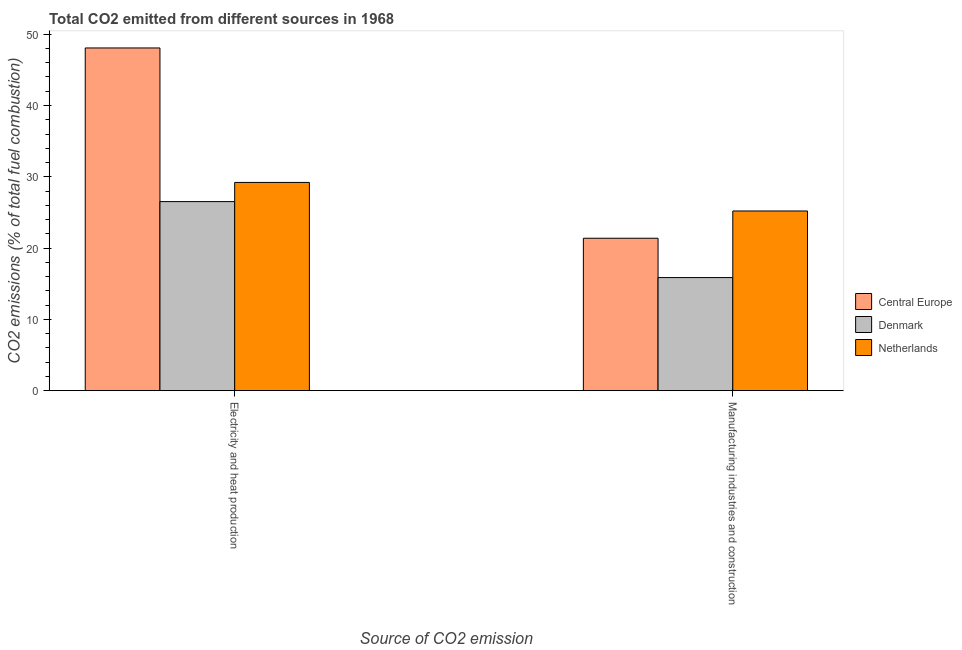How many different coloured bars are there?
Give a very brief answer. 3. Are the number of bars per tick equal to the number of legend labels?
Keep it short and to the point. Yes. How many bars are there on the 2nd tick from the left?
Offer a terse response. 3. How many bars are there on the 1st tick from the right?
Keep it short and to the point. 3. What is the label of the 2nd group of bars from the left?
Offer a terse response. Manufacturing industries and construction. What is the co2 emissions due to manufacturing industries in Denmark?
Give a very brief answer. 15.86. Across all countries, what is the maximum co2 emissions due to manufacturing industries?
Provide a succinct answer. 25.2. Across all countries, what is the minimum co2 emissions due to electricity and heat production?
Provide a succinct answer. 26.52. In which country was the co2 emissions due to manufacturing industries maximum?
Your answer should be very brief. Netherlands. In which country was the co2 emissions due to electricity and heat production minimum?
Offer a terse response. Denmark. What is the total co2 emissions due to electricity and heat production in the graph?
Give a very brief answer. 103.8. What is the difference between the co2 emissions due to manufacturing industries in Denmark and that in Central Europe?
Your answer should be very brief. -5.52. What is the difference between the co2 emissions due to manufacturing industries in Central Europe and the co2 emissions due to electricity and heat production in Denmark?
Provide a succinct answer. -5.14. What is the average co2 emissions due to electricity and heat production per country?
Provide a succinct answer. 34.6. What is the difference between the co2 emissions due to electricity and heat production and co2 emissions due to manufacturing industries in Denmark?
Offer a very short reply. 10.66. In how many countries, is the co2 emissions due to electricity and heat production greater than 12 %?
Provide a succinct answer. 3. What is the ratio of the co2 emissions due to electricity and heat production in Denmark to that in Netherlands?
Give a very brief answer. 0.91. Is the co2 emissions due to electricity and heat production in Central Europe less than that in Denmark?
Ensure brevity in your answer.  No. In how many countries, is the co2 emissions due to manufacturing industries greater than the average co2 emissions due to manufacturing industries taken over all countries?
Your answer should be compact. 2. What does the 1st bar from the left in Electricity and heat production represents?
Offer a very short reply. Central Europe. What is the difference between two consecutive major ticks on the Y-axis?
Keep it short and to the point. 10. Are the values on the major ticks of Y-axis written in scientific E-notation?
Your response must be concise. No. Does the graph contain any zero values?
Keep it short and to the point. No. Does the graph contain grids?
Your answer should be very brief. No. What is the title of the graph?
Your answer should be very brief. Total CO2 emitted from different sources in 1968. Does "Finland" appear as one of the legend labels in the graph?
Ensure brevity in your answer.  No. What is the label or title of the X-axis?
Ensure brevity in your answer.  Source of CO2 emission. What is the label or title of the Y-axis?
Make the answer very short. CO2 emissions (% of total fuel combustion). What is the CO2 emissions (% of total fuel combustion) in Central Europe in Electricity and heat production?
Offer a terse response. 48.07. What is the CO2 emissions (% of total fuel combustion) of Denmark in Electricity and heat production?
Your answer should be very brief. 26.52. What is the CO2 emissions (% of total fuel combustion) in Netherlands in Electricity and heat production?
Keep it short and to the point. 29.21. What is the CO2 emissions (% of total fuel combustion) in Central Europe in Manufacturing industries and construction?
Offer a terse response. 21.38. What is the CO2 emissions (% of total fuel combustion) in Denmark in Manufacturing industries and construction?
Make the answer very short. 15.86. What is the CO2 emissions (% of total fuel combustion) of Netherlands in Manufacturing industries and construction?
Give a very brief answer. 25.2. Across all Source of CO2 emission, what is the maximum CO2 emissions (% of total fuel combustion) of Central Europe?
Give a very brief answer. 48.07. Across all Source of CO2 emission, what is the maximum CO2 emissions (% of total fuel combustion) in Denmark?
Make the answer very short. 26.52. Across all Source of CO2 emission, what is the maximum CO2 emissions (% of total fuel combustion) of Netherlands?
Offer a very short reply. 29.21. Across all Source of CO2 emission, what is the minimum CO2 emissions (% of total fuel combustion) in Central Europe?
Provide a short and direct response. 21.38. Across all Source of CO2 emission, what is the minimum CO2 emissions (% of total fuel combustion) in Denmark?
Keep it short and to the point. 15.86. Across all Source of CO2 emission, what is the minimum CO2 emissions (% of total fuel combustion) of Netherlands?
Ensure brevity in your answer.  25.2. What is the total CO2 emissions (% of total fuel combustion) of Central Europe in the graph?
Offer a terse response. 69.45. What is the total CO2 emissions (% of total fuel combustion) in Denmark in the graph?
Keep it short and to the point. 42.38. What is the total CO2 emissions (% of total fuel combustion) in Netherlands in the graph?
Ensure brevity in your answer.  54.41. What is the difference between the CO2 emissions (% of total fuel combustion) of Central Europe in Electricity and heat production and that in Manufacturing industries and construction?
Ensure brevity in your answer.  26.69. What is the difference between the CO2 emissions (% of total fuel combustion) in Denmark in Electricity and heat production and that in Manufacturing industries and construction?
Keep it short and to the point. 10.66. What is the difference between the CO2 emissions (% of total fuel combustion) of Netherlands in Electricity and heat production and that in Manufacturing industries and construction?
Keep it short and to the point. 4. What is the difference between the CO2 emissions (% of total fuel combustion) of Central Europe in Electricity and heat production and the CO2 emissions (% of total fuel combustion) of Denmark in Manufacturing industries and construction?
Give a very brief answer. 32.21. What is the difference between the CO2 emissions (% of total fuel combustion) of Central Europe in Electricity and heat production and the CO2 emissions (% of total fuel combustion) of Netherlands in Manufacturing industries and construction?
Provide a short and direct response. 22.87. What is the difference between the CO2 emissions (% of total fuel combustion) in Denmark in Electricity and heat production and the CO2 emissions (% of total fuel combustion) in Netherlands in Manufacturing industries and construction?
Your answer should be compact. 1.31. What is the average CO2 emissions (% of total fuel combustion) in Central Europe per Source of CO2 emission?
Provide a short and direct response. 34.73. What is the average CO2 emissions (% of total fuel combustion) of Denmark per Source of CO2 emission?
Offer a terse response. 21.19. What is the average CO2 emissions (% of total fuel combustion) in Netherlands per Source of CO2 emission?
Make the answer very short. 27.21. What is the difference between the CO2 emissions (% of total fuel combustion) of Central Europe and CO2 emissions (% of total fuel combustion) of Denmark in Electricity and heat production?
Provide a succinct answer. 21.55. What is the difference between the CO2 emissions (% of total fuel combustion) in Central Europe and CO2 emissions (% of total fuel combustion) in Netherlands in Electricity and heat production?
Provide a short and direct response. 18.86. What is the difference between the CO2 emissions (% of total fuel combustion) in Denmark and CO2 emissions (% of total fuel combustion) in Netherlands in Electricity and heat production?
Offer a terse response. -2.69. What is the difference between the CO2 emissions (% of total fuel combustion) in Central Europe and CO2 emissions (% of total fuel combustion) in Denmark in Manufacturing industries and construction?
Ensure brevity in your answer.  5.52. What is the difference between the CO2 emissions (% of total fuel combustion) in Central Europe and CO2 emissions (% of total fuel combustion) in Netherlands in Manufacturing industries and construction?
Your answer should be compact. -3.82. What is the difference between the CO2 emissions (% of total fuel combustion) of Denmark and CO2 emissions (% of total fuel combustion) of Netherlands in Manufacturing industries and construction?
Provide a succinct answer. -9.34. What is the ratio of the CO2 emissions (% of total fuel combustion) in Central Europe in Electricity and heat production to that in Manufacturing industries and construction?
Provide a short and direct response. 2.25. What is the ratio of the CO2 emissions (% of total fuel combustion) in Denmark in Electricity and heat production to that in Manufacturing industries and construction?
Offer a terse response. 1.67. What is the ratio of the CO2 emissions (% of total fuel combustion) in Netherlands in Electricity and heat production to that in Manufacturing industries and construction?
Give a very brief answer. 1.16. What is the difference between the highest and the second highest CO2 emissions (% of total fuel combustion) of Central Europe?
Your answer should be very brief. 26.69. What is the difference between the highest and the second highest CO2 emissions (% of total fuel combustion) in Denmark?
Provide a short and direct response. 10.66. What is the difference between the highest and the second highest CO2 emissions (% of total fuel combustion) of Netherlands?
Your response must be concise. 4. What is the difference between the highest and the lowest CO2 emissions (% of total fuel combustion) in Central Europe?
Provide a short and direct response. 26.69. What is the difference between the highest and the lowest CO2 emissions (% of total fuel combustion) of Denmark?
Offer a terse response. 10.66. What is the difference between the highest and the lowest CO2 emissions (% of total fuel combustion) in Netherlands?
Your response must be concise. 4. 